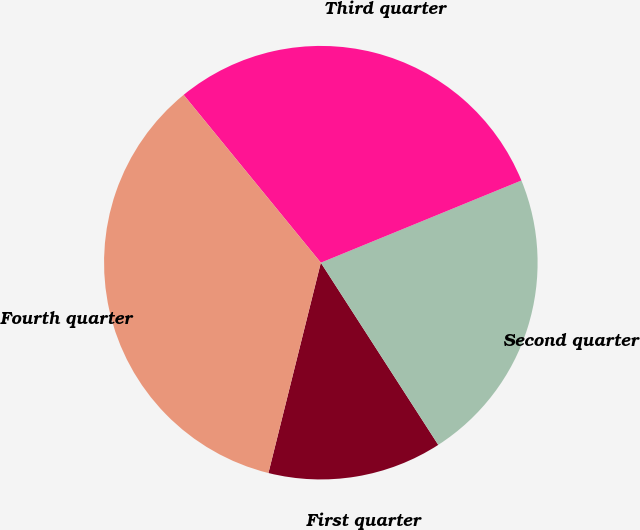Convert chart to OTSL. <chart><loc_0><loc_0><loc_500><loc_500><pie_chart><fcel>First quarter<fcel>Second quarter<fcel>Third quarter<fcel>Fourth quarter<nl><fcel>13.0%<fcel>22.08%<fcel>29.72%<fcel>35.21%<nl></chart> 